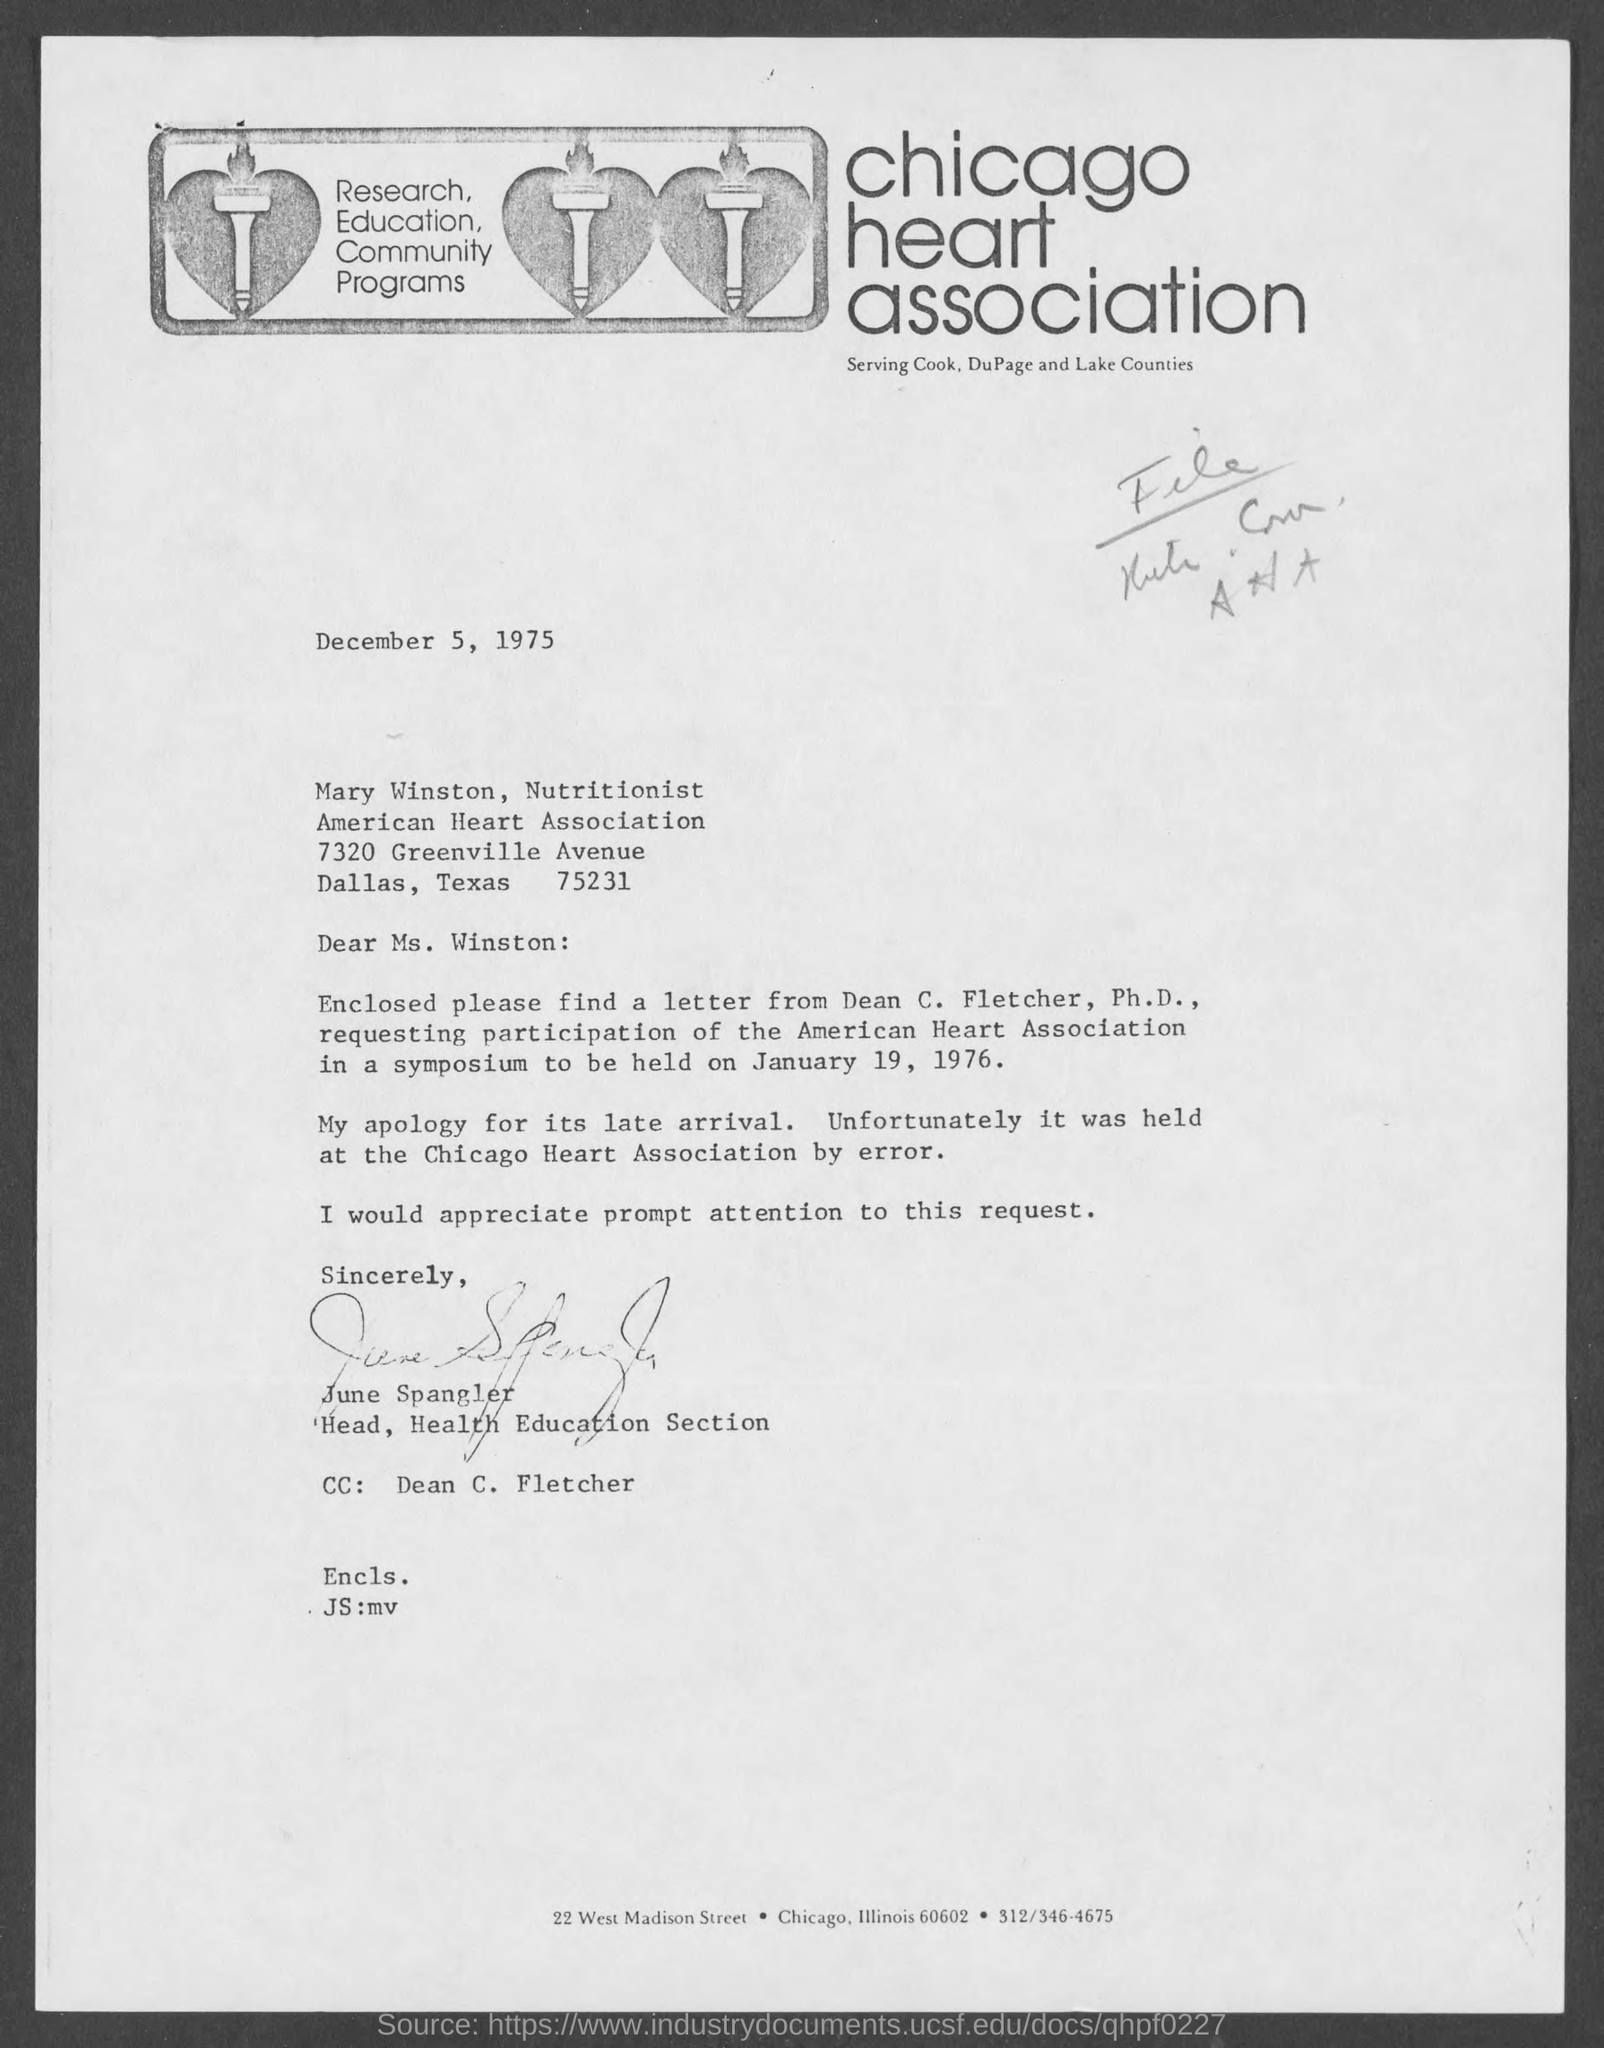Mention a couple of crucial points in this snapshot. June Spangler holds the designation of Head of the Health Education Section. The Chicago Heart Association is mentioned in the letterhead. The issued date of this letter is December 5, 1975. The letter has been signed by June Spangler. 